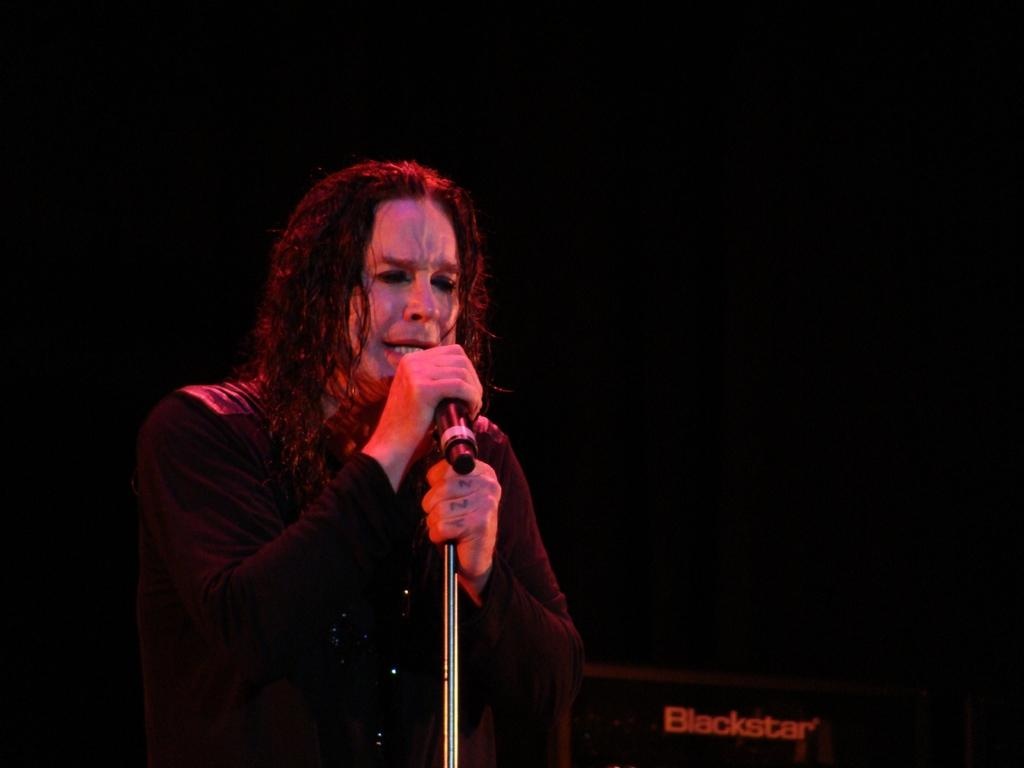Who is the main subject in the image? There is a person in the image. What is the person wearing? The person is wearing a black dress. What is the person holding in the image? The person is holding a microphone. What is the person doing in the image? The person is singing. What can be seen on the right side of the image? There is a speaker on the right side of the image. What is the texture of the back of the person's dress in the image? The provided facts do not mention the texture of the dress, so it cannot be determined from the image. 